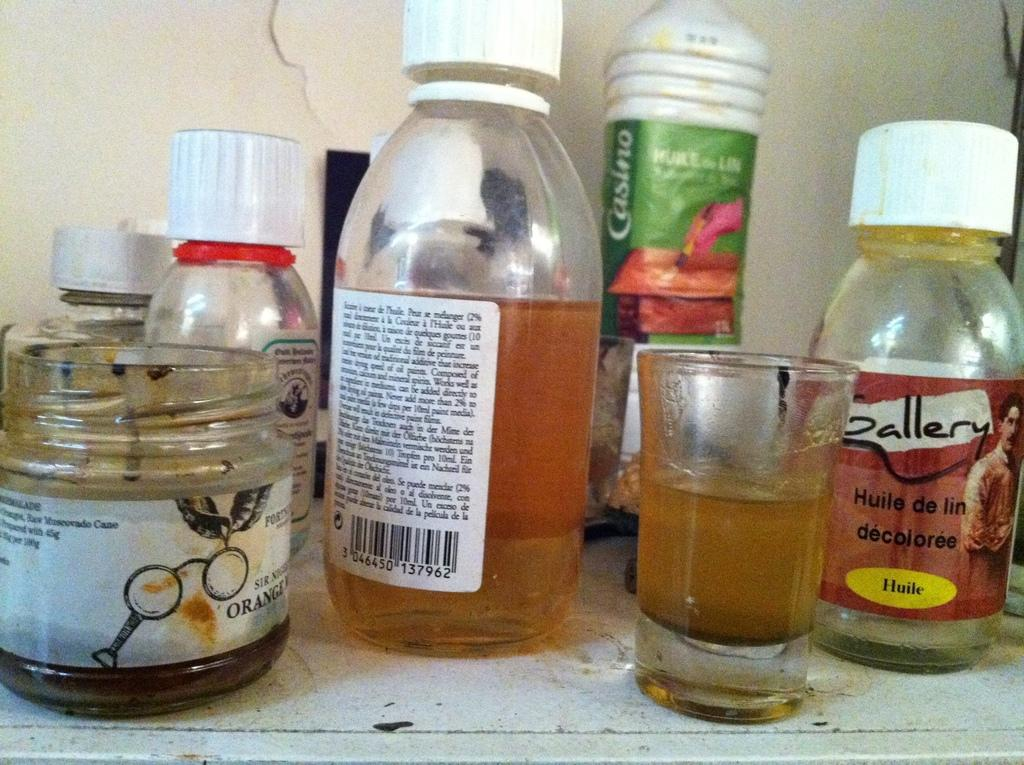What types of containers are visible in the image? There are bottles, a jar, and a glass in the image. What type of key is used to unlock the anger in the image? There is no key or anger present in the image; it only features bottles, a jar, and a glass. 